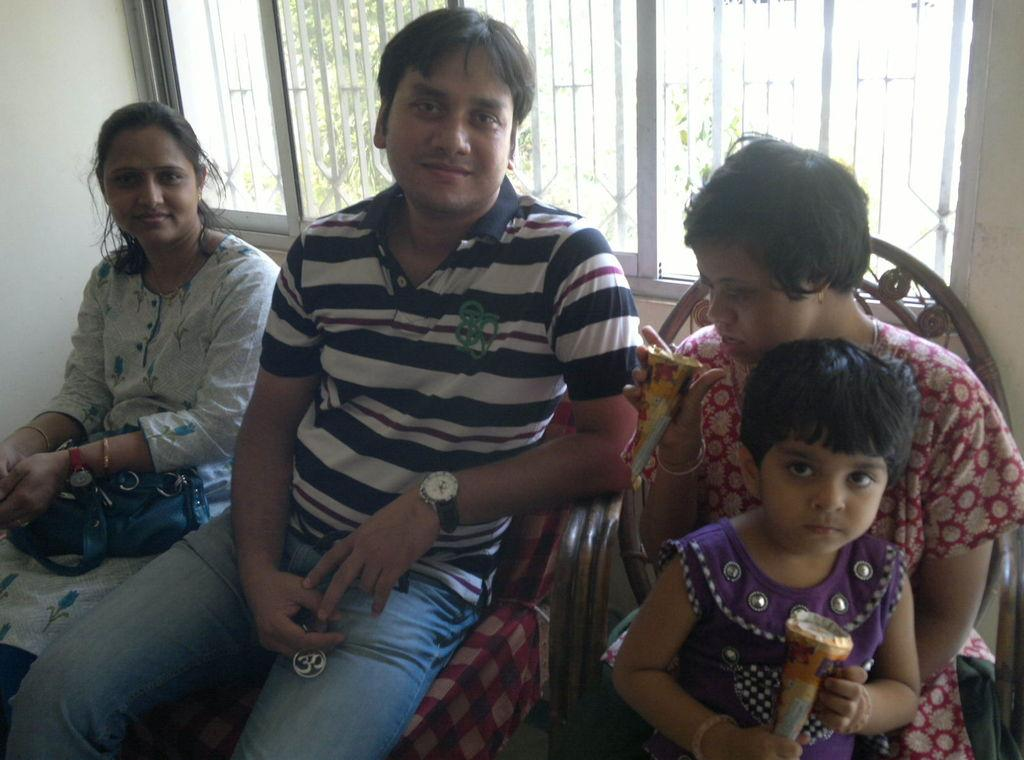How many people are in the image? There are people in the image, but the exact number is not specified. What type of furniture is present in the image? There are chairs in the image. What architectural feature can be seen in the image? There is a window and a wall in the image. What can be seen in the background of the image? There are trees in the background of the image. What is the girl on the right side of the image holding? The girl on the right side of the image is holding a food item. What type of glue is being used by the army in the image? There is no mention of glue or the army in the image, so this question cannot be answered. 